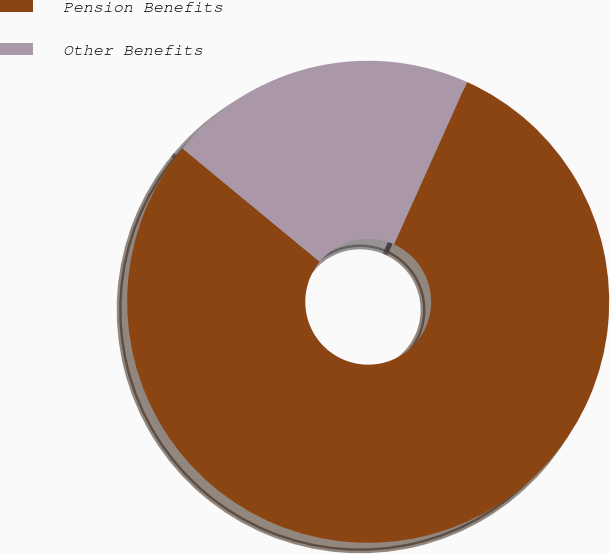<chart> <loc_0><loc_0><loc_500><loc_500><pie_chart><fcel>Pension Benefits<fcel>Other Benefits<nl><fcel>79.27%<fcel>20.73%<nl></chart> 